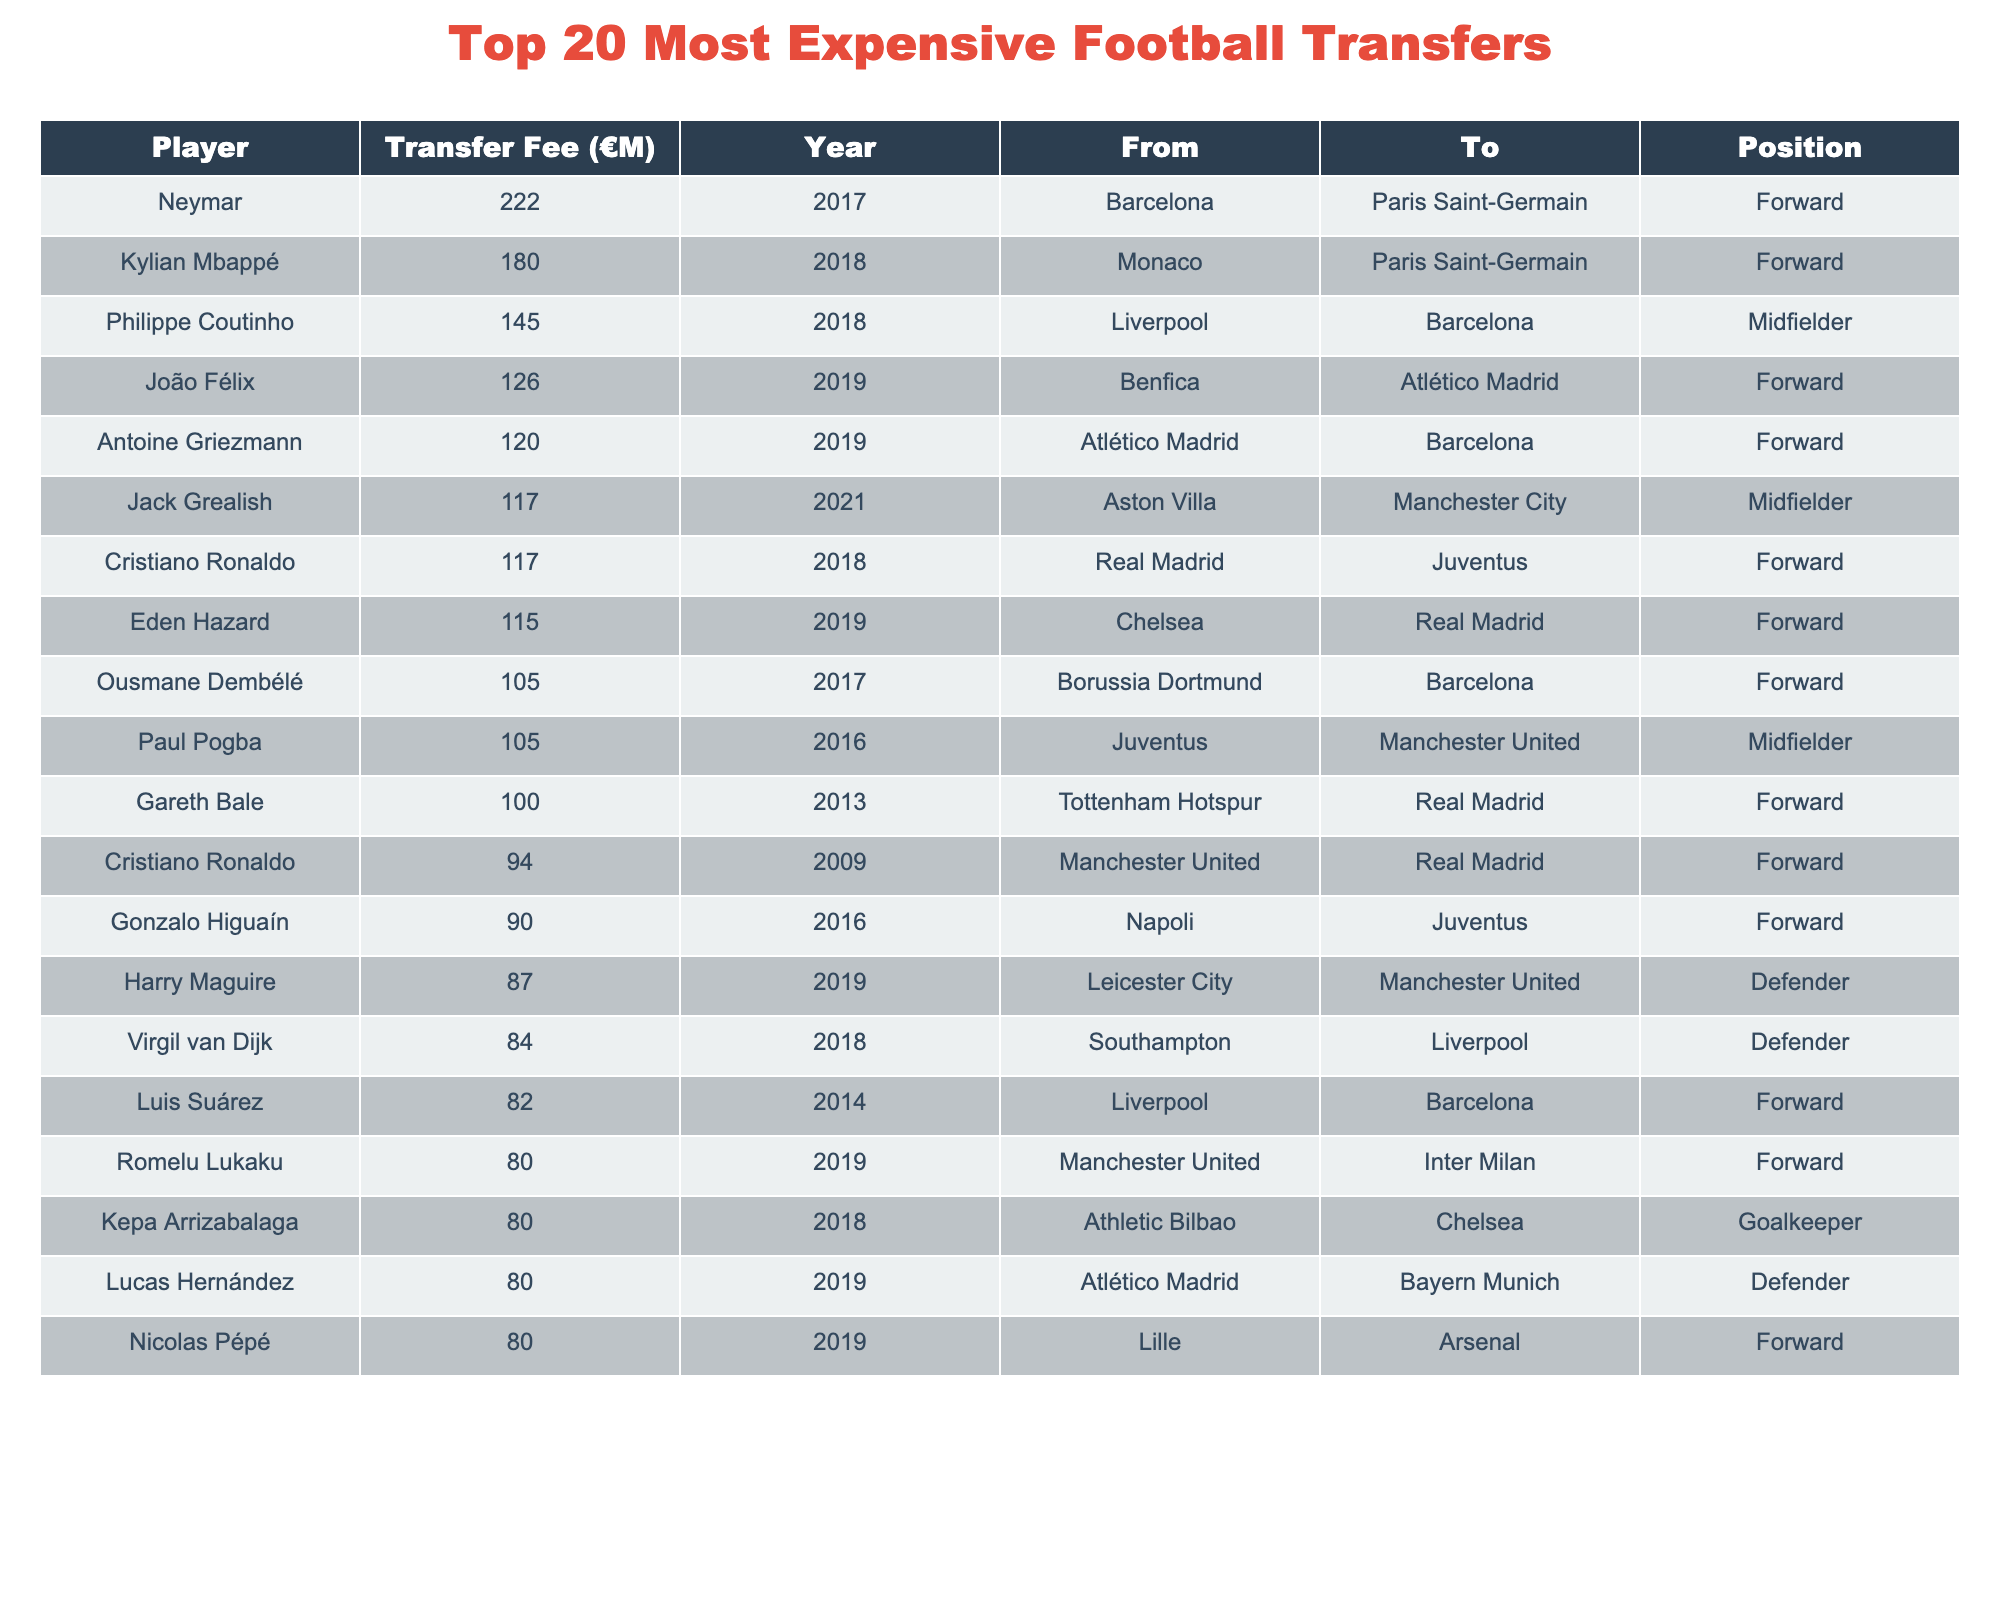What's the highest transfer fee listed in the table? The highest transfer fee in the table is for Neymar, which is 222 million euros.
Answer: 222 million euros Which player was transferred in the year 2019 for the highest fee? João Félix was transferred in 2019 for 126 million euros, which is the highest fee for that year listed in the table.
Answer: João Félix How many players transferred for over 100 million euros? The players who transferred for over 100 million euros are Neymar, Kylian Mbappé, Philippe Coutinho, João Félix, Antoine Griezmann, Jack Grealish, Cristiano Ronaldo, Eden Hazard, Ousmane Dembélé, and Paul Pogba, making a total of 10 players.
Answer: 10 players What was the total transfer fee of the top three transfers? The top three transfer fees are Neymar (222) + Kylian Mbappé (180) + Philippe Coutinho (145), which totals to 547 million euros.
Answer: 547 million euros Which positions dominate the list of top transfers? The majority of players in the top 20 transfers are forwards, with 13 forwards compared to 5 midfielders and 2 defenders.
Answer: Forwards dominate Is there any player who has been involved in multiple of the top transfers? Yes, Cristiano Ronaldo appears twice in the table, once for his transfer in 2009 and again in 2018.
Answer: Yes What's the average transfer fee of the top 20 transfers? To calculate the average, sum all transfer fees: 222 + 180 + 145 + 126 + 120 + 117 + 117 + 115 + 105 + 105 + 100 + 94 + 90 + 87 + 84 + 82 + 80 + 80 + 80 + 80 = 1,573 million euros. Then, divide this by 20: 1,573/20 = 78.65 million euros.
Answer: 78.65 million euros What year saw the most player transfers above 80 million euros? In 2019, four players were transferred for over 80 million euros: João Félix, Antoine Griezmann, Eden Hazard, and Kepa Arrizabalaga.
Answer: 2019 Which club sold the most expensive player and for how much? Barcelona sold Neymar to Paris Saint-Germain for 222 million euros, making it the most expensive transfer.
Answer: Barcelona, 222 million euros How many transfers were made to Paris Saint-Germain? Paris Saint-Germain is listed as the receiving club for three transfers: Neymar, Kylian Mbappé, and for a player who appears in the table but was not transferred.
Answer: 2 transfers to Paris Saint-Germain 